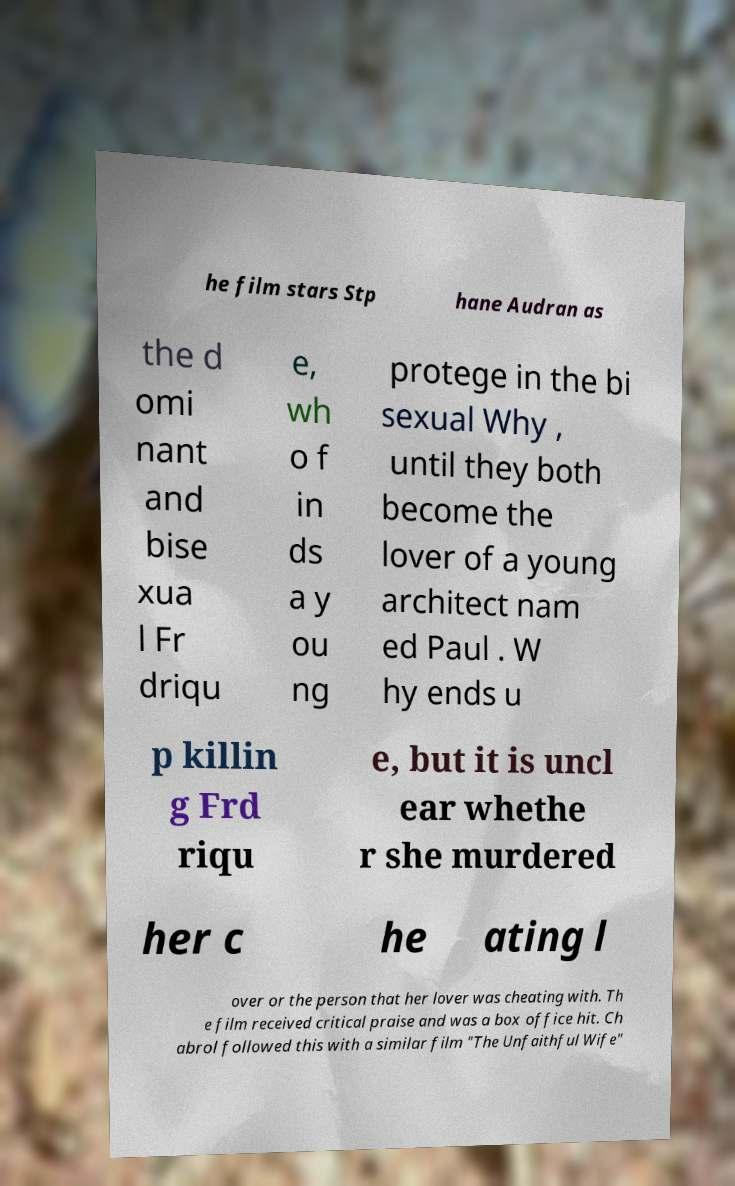I need the written content from this picture converted into text. Can you do that? he film stars Stp hane Audran as the d omi nant and bise xua l Fr driqu e, wh o f in ds a y ou ng protege in the bi sexual Why , until they both become the lover of a young architect nam ed Paul . W hy ends u p killin g Frd riqu e, but it is uncl ear whethe r she murdered her c he ating l over or the person that her lover was cheating with. Th e film received critical praise and was a box office hit. Ch abrol followed this with a similar film "The Unfaithful Wife" 